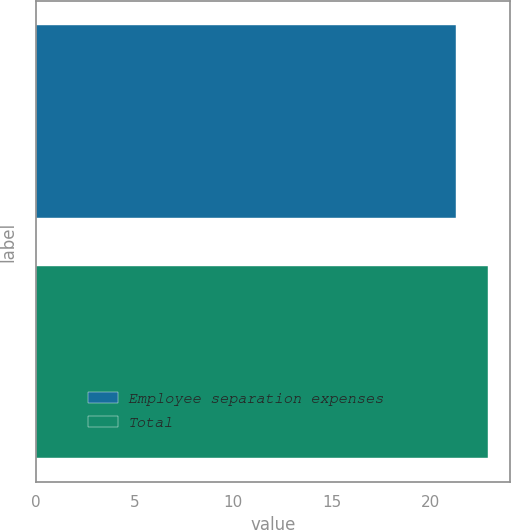Convert chart. <chart><loc_0><loc_0><loc_500><loc_500><bar_chart><fcel>Employee separation expenses<fcel>Total<nl><fcel>21.3<fcel>22.9<nl></chart> 